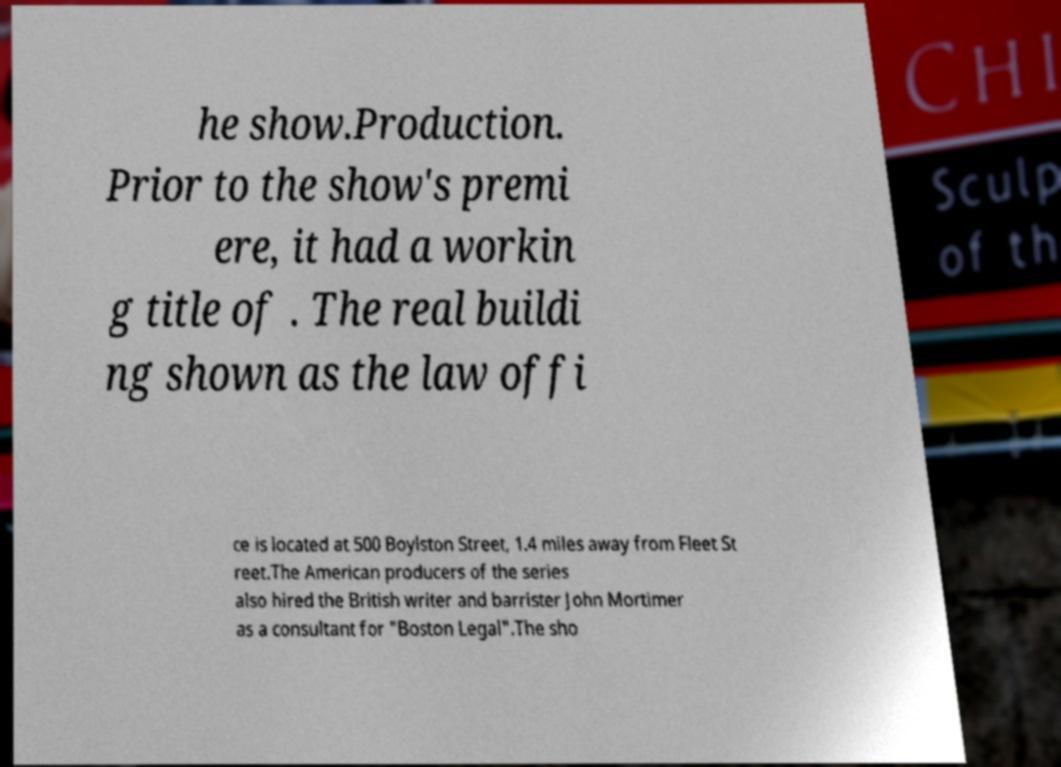There's text embedded in this image that I need extracted. Can you transcribe it verbatim? he show.Production. Prior to the show's premi ere, it had a workin g title of . The real buildi ng shown as the law offi ce is located at 500 Boylston Street, 1.4 miles away from Fleet St reet.The American producers of the series also hired the British writer and barrister John Mortimer as a consultant for "Boston Legal".The sho 